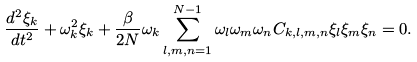<formula> <loc_0><loc_0><loc_500><loc_500>\frac { d ^ { 2 } \xi _ { k } } { d t ^ { 2 } } + \omega _ { k } ^ { 2 } \xi _ { k } + \frac { \beta } { 2 N } \omega _ { k } \sum _ { l , m , n = 1 } ^ { N - 1 } \omega _ { l } \omega _ { m } \omega _ { n } C _ { k , l , m , n } \xi _ { l } \xi _ { m } \xi _ { n } = 0 .</formula> 